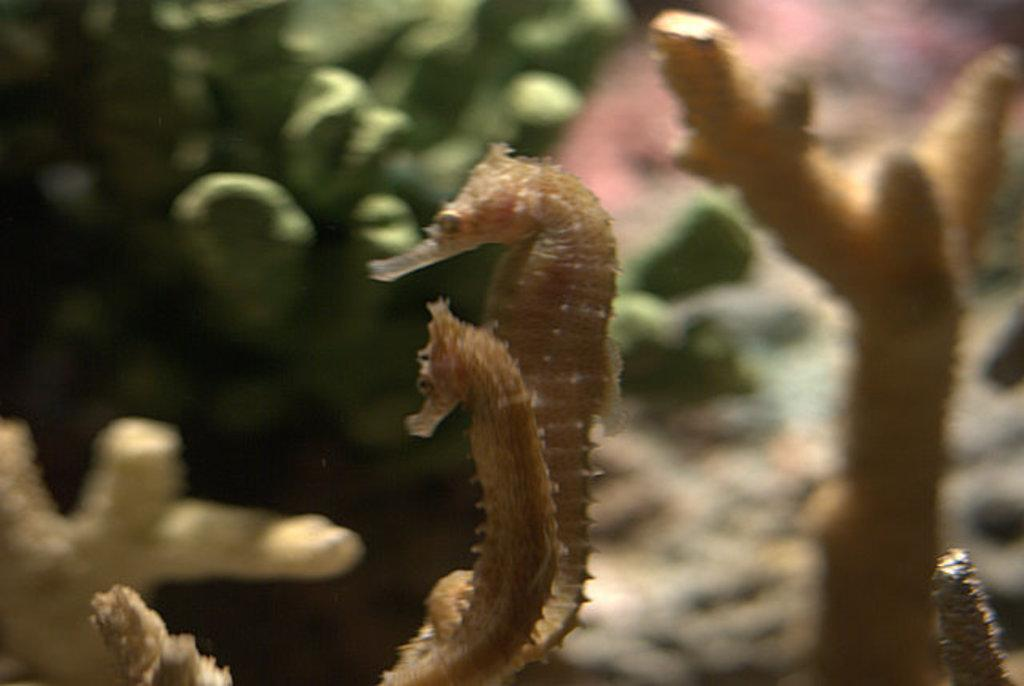What type of marine animals are in the image? There are northern seahorses in the image. What other elements can be seen in the image besides the seahorses? There are plants in the image. What type of twig can be seen in the image? There is no twig present in the image; it features northern seahorses and plants. How many brothers are visible in the image? There are no people, let alone brothers, present in the image. 